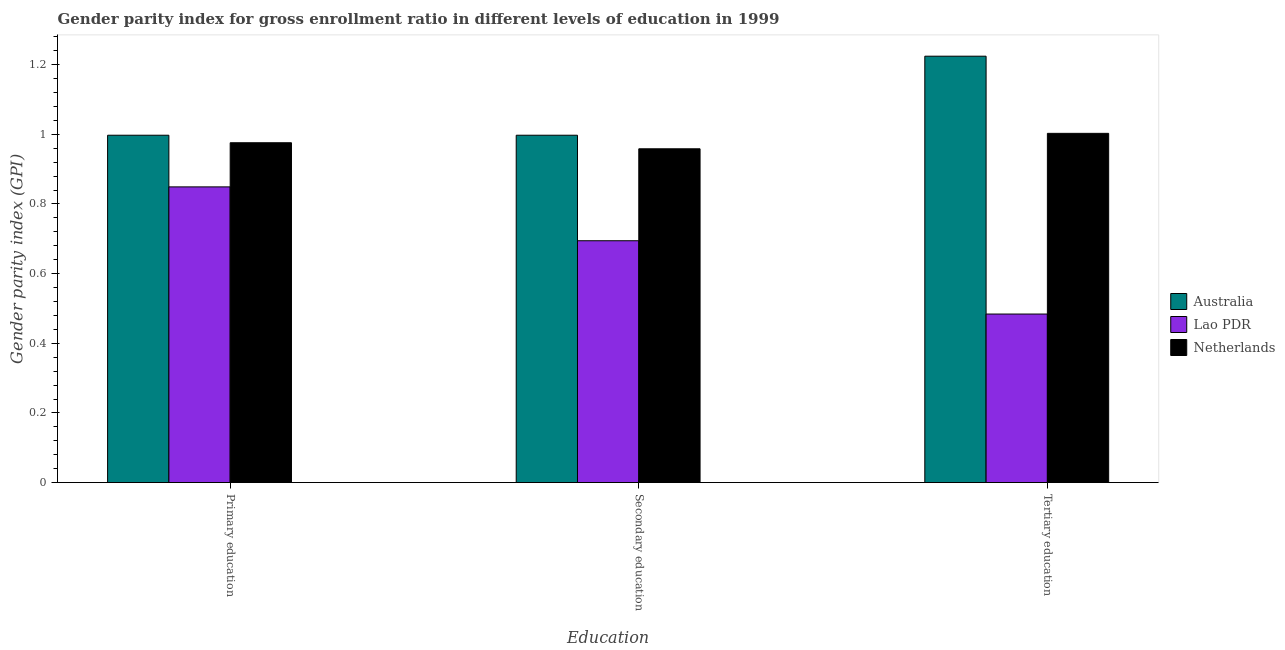How many groups of bars are there?
Keep it short and to the point. 3. Are the number of bars per tick equal to the number of legend labels?
Keep it short and to the point. Yes. How many bars are there on the 2nd tick from the right?
Keep it short and to the point. 3. What is the label of the 3rd group of bars from the left?
Keep it short and to the point. Tertiary education. What is the gender parity index in tertiary education in Lao PDR?
Provide a succinct answer. 0.48. Across all countries, what is the maximum gender parity index in secondary education?
Your response must be concise. 1. Across all countries, what is the minimum gender parity index in secondary education?
Make the answer very short. 0.69. In which country was the gender parity index in tertiary education maximum?
Make the answer very short. Australia. In which country was the gender parity index in primary education minimum?
Provide a short and direct response. Lao PDR. What is the total gender parity index in tertiary education in the graph?
Ensure brevity in your answer.  2.71. What is the difference between the gender parity index in primary education in Lao PDR and that in Australia?
Your answer should be very brief. -0.15. What is the difference between the gender parity index in primary education in Australia and the gender parity index in tertiary education in Netherlands?
Your answer should be very brief. -0.01. What is the average gender parity index in primary education per country?
Your response must be concise. 0.94. What is the difference between the gender parity index in tertiary education and gender parity index in secondary education in Lao PDR?
Give a very brief answer. -0.21. What is the ratio of the gender parity index in secondary education in Australia to that in Lao PDR?
Your answer should be compact. 1.44. Is the gender parity index in secondary education in Lao PDR less than that in Australia?
Your answer should be compact. Yes. What is the difference between the highest and the second highest gender parity index in primary education?
Offer a very short reply. 0.02. What is the difference between the highest and the lowest gender parity index in tertiary education?
Keep it short and to the point. 0.74. In how many countries, is the gender parity index in secondary education greater than the average gender parity index in secondary education taken over all countries?
Make the answer very short. 2. Is the sum of the gender parity index in primary education in Lao PDR and Australia greater than the maximum gender parity index in tertiary education across all countries?
Ensure brevity in your answer.  Yes. What does the 3rd bar from the left in Secondary education represents?
Give a very brief answer. Netherlands. What does the 1st bar from the right in Secondary education represents?
Offer a terse response. Netherlands. Is it the case that in every country, the sum of the gender parity index in primary education and gender parity index in secondary education is greater than the gender parity index in tertiary education?
Give a very brief answer. Yes. How many bars are there?
Make the answer very short. 9. Are all the bars in the graph horizontal?
Your response must be concise. No. What is the difference between two consecutive major ticks on the Y-axis?
Make the answer very short. 0.2. Are the values on the major ticks of Y-axis written in scientific E-notation?
Provide a short and direct response. No. Does the graph contain any zero values?
Your answer should be compact. No. Does the graph contain grids?
Make the answer very short. No. Where does the legend appear in the graph?
Offer a terse response. Center right. How many legend labels are there?
Your response must be concise. 3. How are the legend labels stacked?
Your response must be concise. Vertical. What is the title of the graph?
Provide a succinct answer. Gender parity index for gross enrollment ratio in different levels of education in 1999. What is the label or title of the X-axis?
Provide a short and direct response. Education. What is the label or title of the Y-axis?
Your response must be concise. Gender parity index (GPI). What is the Gender parity index (GPI) in Australia in Primary education?
Provide a short and direct response. 1. What is the Gender parity index (GPI) of Lao PDR in Primary education?
Your answer should be compact. 0.85. What is the Gender parity index (GPI) in Netherlands in Primary education?
Offer a very short reply. 0.98. What is the Gender parity index (GPI) of Australia in Secondary education?
Give a very brief answer. 1. What is the Gender parity index (GPI) of Lao PDR in Secondary education?
Offer a very short reply. 0.69. What is the Gender parity index (GPI) in Netherlands in Secondary education?
Provide a succinct answer. 0.96. What is the Gender parity index (GPI) of Australia in Tertiary education?
Ensure brevity in your answer.  1.22. What is the Gender parity index (GPI) in Lao PDR in Tertiary education?
Offer a very short reply. 0.48. What is the Gender parity index (GPI) of Netherlands in Tertiary education?
Your answer should be compact. 1. Across all Education, what is the maximum Gender parity index (GPI) in Australia?
Keep it short and to the point. 1.22. Across all Education, what is the maximum Gender parity index (GPI) of Lao PDR?
Keep it short and to the point. 0.85. Across all Education, what is the maximum Gender parity index (GPI) in Netherlands?
Your response must be concise. 1. Across all Education, what is the minimum Gender parity index (GPI) in Australia?
Make the answer very short. 1. Across all Education, what is the minimum Gender parity index (GPI) of Lao PDR?
Offer a very short reply. 0.48. Across all Education, what is the minimum Gender parity index (GPI) in Netherlands?
Make the answer very short. 0.96. What is the total Gender parity index (GPI) in Australia in the graph?
Offer a very short reply. 3.22. What is the total Gender parity index (GPI) of Lao PDR in the graph?
Your answer should be very brief. 2.03. What is the total Gender parity index (GPI) of Netherlands in the graph?
Your answer should be very brief. 2.94. What is the difference between the Gender parity index (GPI) of Australia in Primary education and that in Secondary education?
Your answer should be compact. 0. What is the difference between the Gender parity index (GPI) in Lao PDR in Primary education and that in Secondary education?
Your answer should be compact. 0.15. What is the difference between the Gender parity index (GPI) of Netherlands in Primary education and that in Secondary education?
Make the answer very short. 0.02. What is the difference between the Gender parity index (GPI) in Australia in Primary education and that in Tertiary education?
Give a very brief answer. -0.23. What is the difference between the Gender parity index (GPI) of Lao PDR in Primary education and that in Tertiary education?
Offer a terse response. 0.36. What is the difference between the Gender parity index (GPI) of Netherlands in Primary education and that in Tertiary education?
Make the answer very short. -0.03. What is the difference between the Gender parity index (GPI) in Australia in Secondary education and that in Tertiary education?
Provide a succinct answer. -0.23. What is the difference between the Gender parity index (GPI) of Lao PDR in Secondary education and that in Tertiary education?
Make the answer very short. 0.21. What is the difference between the Gender parity index (GPI) in Netherlands in Secondary education and that in Tertiary education?
Provide a succinct answer. -0.04. What is the difference between the Gender parity index (GPI) in Australia in Primary education and the Gender parity index (GPI) in Lao PDR in Secondary education?
Your answer should be compact. 0.3. What is the difference between the Gender parity index (GPI) of Australia in Primary education and the Gender parity index (GPI) of Netherlands in Secondary education?
Provide a short and direct response. 0.04. What is the difference between the Gender parity index (GPI) in Lao PDR in Primary education and the Gender parity index (GPI) in Netherlands in Secondary education?
Keep it short and to the point. -0.11. What is the difference between the Gender parity index (GPI) of Australia in Primary education and the Gender parity index (GPI) of Lao PDR in Tertiary education?
Provide a short and direct response. 0.51. What is the difference between the Gender parity index (GPI) of Australia in Primary education and the Gender parity index (GPI) of Netherlands in Tertiary education?
Offer a very short reply. -0.01. What is the difference between the Gender parity index (GPI) in Lao PDR in Primary education and the Gender parity index (GPI) in Netherlands in Tertiary education?
Your answer should be very brief. -0.15. What is the difference between the Gender parity index (GPI) in Australia in Secondary education and the Gender parity index (GPI) in Lao PDR in Tertiary education?
Your answer should be compact. 0.51. What is the difference between the Gender parity index (GPI) in Australia in Secondary education and the Gender parity index (GPI) in Netherlands in Tertiary education?
Offer a very short reply. -0.01. What is the difference between the Gender parity index (GPI) of Lao PDR in Secondary education and the Gender parity index (GPI) of Netherlands in Tertiary education?
Make the answer very short. -0.31. What is the average Gender parity index (GPI) of Australia per Education?
Make the answer very short. 1.07. What is the average Gender parity index (GPI) of Lao PDR per Education?
Provide a short and direct response. 0.68. What is the difference between the Gender parity index (GPI) of Australia and Gender parity index (GPI) of Lao PDR in Primary education?
Make the answer very short. 0.15. What is the difference between the Gender parity index (GPI) of Australia and Gender parity index (GPI) of Netherlands in Primary education?
Offer a terse response. 0.02. What is the difference between the Gender parity index (GPI) in Lao PDR and Gender parity index (GPI) in Netherlands in Primary education?
Make the answer very short. -0.13. What is the difference between the Gender parity index (GPI) in Australia and Gender parity index (GPI) in Lao PDR in Secondary education?
Offer a terse response. 0.3. What is the difference between the Gender parity index (GPI) in Australia and Gender parity index (GPI) in Netherlands in Secondary education?
Provide a short and direct response. 0.04. What is the difference between the Gender parity index (GPI) in Lao PDR and Gender parity index (GPI) in Netherlands in Secondary education?
Give a very brief answer. -0.26. What is the difference between the Gender parity index (GPI) in Australia and Gender parity index (GPI) in Lao PDR in Tertiary education?
Give a very brief answer. 0.74. What is the difference between the Gender parity index (GPI) of Australia and Gender parity index (GPI) of Netherlands in Tertiary education?
Provide a short and direct response. 0.22. What is the difference between the Gender parity index (GPI) of Lao PDR and Gender parity index (GPI) of Netherlands in Tertiary education?
Offer a very short reply. -0.52. What is the ratio of the Gender parity index (GPI) in Lao PDR in Primary education to that in Secondary education?
Your answer should be very brief. 1.22. What is the ratio of the Gender parity index (GPI) in Netherlands in Primary education to that in Secondary education?
Your answer should be very brief. 1.02. What is the ratio of the Gender parity index (GPI) of Australia in Primary education to that in Tertiary education?
Offer a very short reply. 0.81. What is the ratio of the Gender parity index (GPI) in Lao PDR in Primary education to that in Tertiary education?
Your answer should be compact. 1.75. What is the ratio of the Gender parity index (GPI) of Netherlands in Primary education to that in Tertiary education?
Keep it short and to the point. 0.97. What is the ratio of the Gender parity index (GPI) of Australia in Secondary education to that in Tertiary education?
Make the answer very short. 0.81. What is the ratio of the Gender parity index (GPI) of Lao PDR in Secondary education to that in Tertiary education?
Provide a succinct answer. 1.43. What is the ratio of the Gender parity index (GPI) in Netherlands in Secondary education to that in Tertiary education?
Your answer should be very brief. 0.96. What is the difference between the highest and the second highest Gender parity index (GPI) of Australia?
Ensure brevity in your answer.  0.23. What is the difference between the highest and the second highest Gender parity index (GPI) in Lao PDR?
Provide a succinct answer. 0.15. What is the difference between the highest and the second highest Gender parity index (GPI) of Netherlands?
Give a very brief answer. 0.03. What is the difference between the highest and the lowest Gender parity index (GPI) of Australia?
Provide a short and direct response. 0.23. What is the difference between the highest and the lowest Gender parity index (GPI) of Lao PDR?
Offer a very short reply. 0.36. What is the difference between the highest and the lowest Gender parity index (GPI) of Netherlands?
Provide a succinct answer. 0.04. 